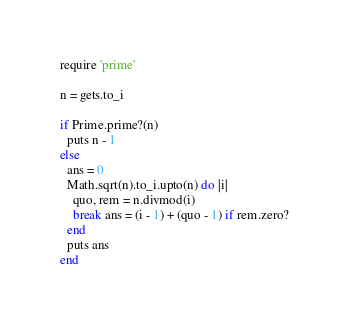<code> <loc_0><loc_0><loc_500><loc_500><_Ruby_>require 'prime'

n = gets.to_i

if Prime.prime?(n)
  puts n - 1
else
  ans = 0
  Math.sqrt(n).to_i.upto(n) do |i|
    quo, rem = n.divmod(i)
    break ans = (i - 1) + (quo - 1) if rem.zero?
  end
  puts ans
end</code> 